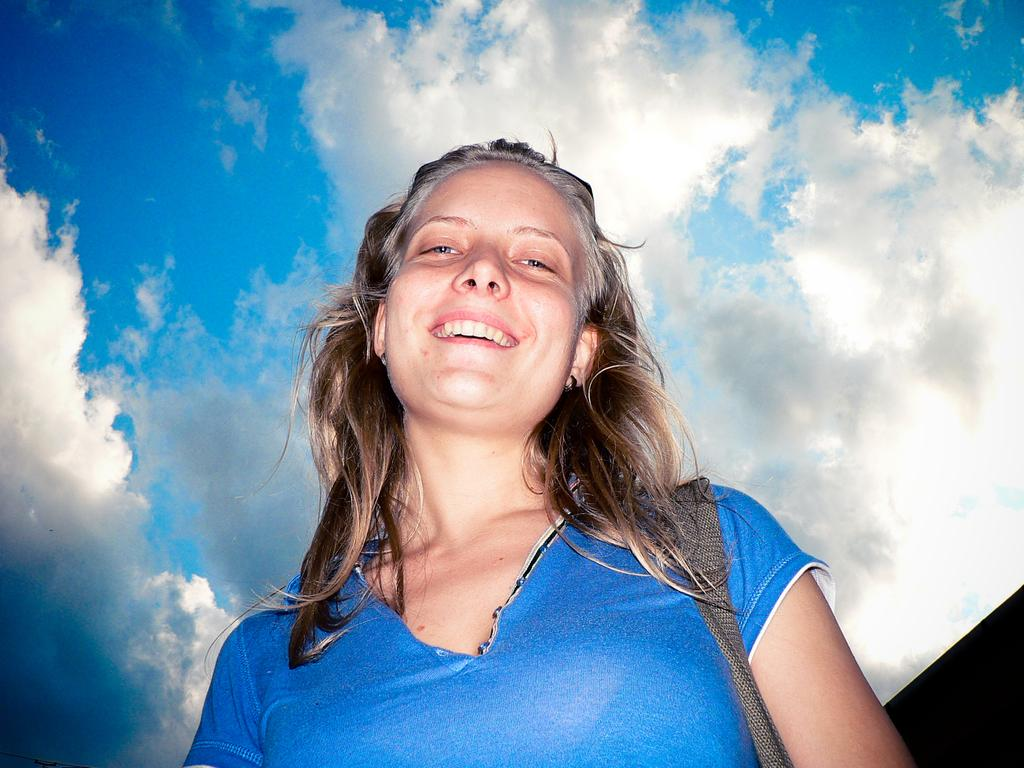Who is present in the image? There is a woman in the image. What is the woman wearing? The woman is wearing clothes. What is the woman's facial expression in the image? The woman is smiling. What is the condition of the sky in the image? The sky is cloudy and blue in the image. What type of cheese is the woman holding in the image? There is no cheese present in the image. Can you describe the woman's boots in the image? There is no mention of boots in the image; the woman is wearing clothes, but no specific details about footwear are provided. 